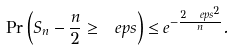Convert formula to latex. <formula><loc_0><loc_0><loc_500><loc_500>\Pr \left ( S _ { n } - \frac { n } { 2 } \geq \ e p s \right ) \leq e ^ { - \frac { 2 \ e p s ^ { 2 } } { n } } .</formula> 